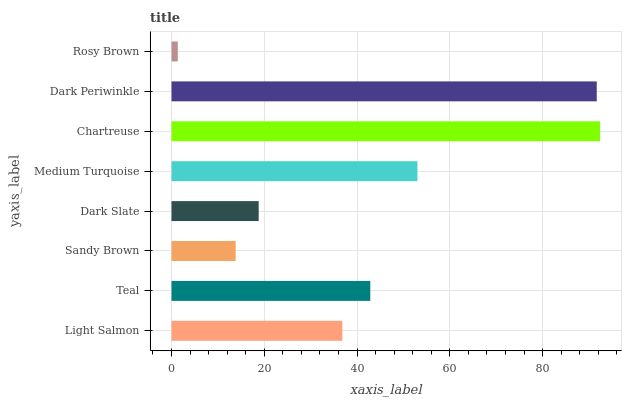Is Rosy Brown the minimum?
Answer yes or no. Yes. Is Chartreuse the maximum?
Answer yes or no. Yes. Is Teal the minimum?
Answer yes or no. No. Is Teal the maximum?
Answer yes or no. No. Is Teal greater than Light Salmon?
Answer yes or no. Yes. Is Light Salmon less than Teal?
Answer yes or no. Yes. Is Light Salmon greater than Teal?
Answer yes or no. No. Is Teal less than Light Salmon?
Answer yes or no. No. Is Teal the high median?
Answer yes or no. Yes. Is Light Salmon the low median?
Answer yes or no. Yes. Is Dark Periwinkle the high median?
Answer yes or no. No. Is Sandy Brown the low median?
Answer yes or no. No. 